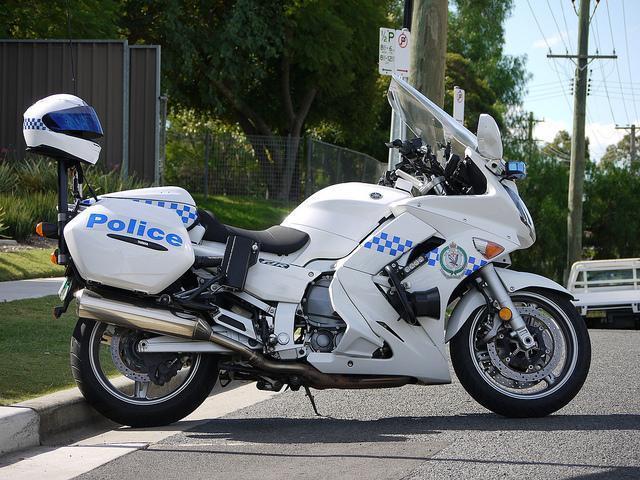How many bikes are in the photo?
Give a very brief answer. 1. How many steps are there?
Give a very brief answer. 0. How many motorcycles can you see?
Give a very brief answer. 1. How many benches are on the left of the room?
Give a very brief answer. 0. 